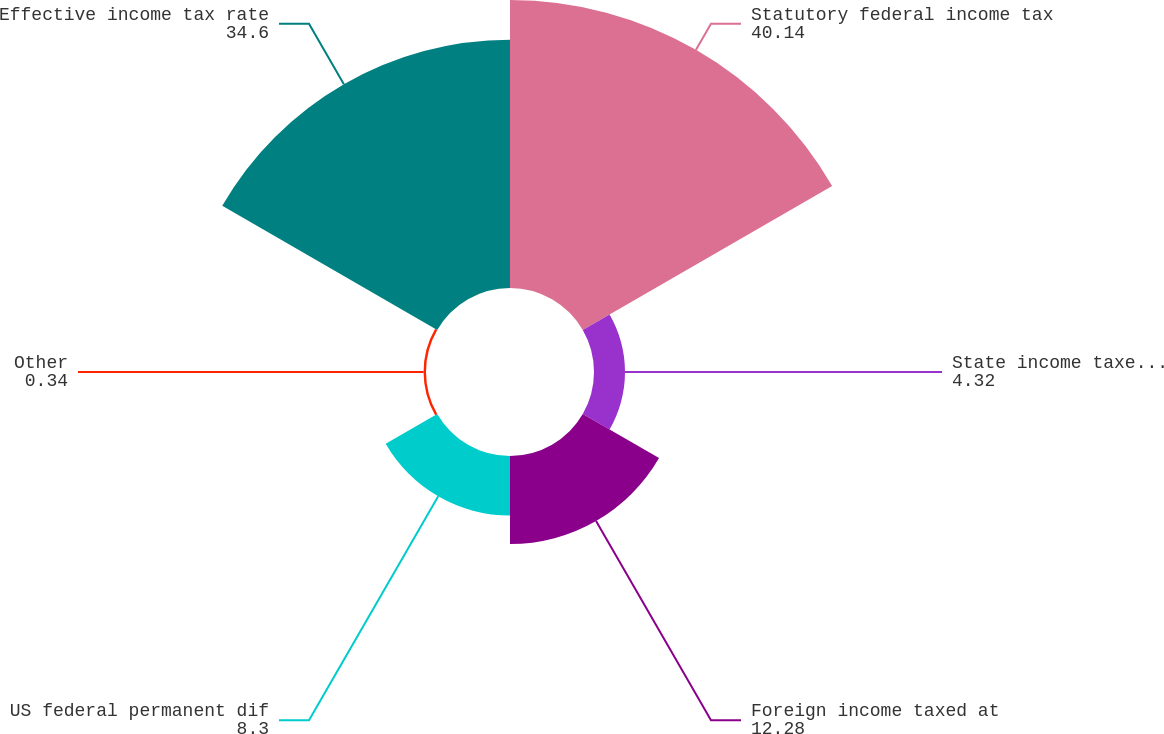<chart> <loc_0><loc_0><loc_500><loc_500><pie_chart><fcel>Statutory federal income tax<fcel>State income taxes (net of<fcel>Foreign income taxed at<fcel>US federal permanent dif<fcel>Other<fcel>Effective income tax rate<nl><fcel>40.14%<fcel>4.32%<fcel>12.28%<fcel>8.3%<fcel>0.34%<fcel>34.6%<nl></chart> 